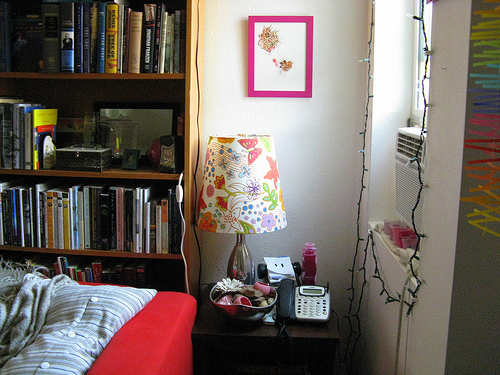<image>
Is the sofa under the shelf? No. The sofa is not positioned under the shelf. The vertical relationship between these objects is different. Is the frame above the phone? Yes. The frame is positioned above the phone in the vertical space, higher up in the scene. 